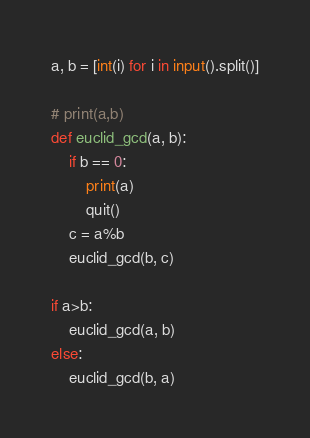Convert code to text. <code><loc_0><loc_0><loc_500><loc_500><_Python_>a, b = [int(i) for i in input().split()]

# print(a,b)
def euclid_gcd(a, b):
    if b == 0:
        print(a)
        quit()
    c = a%b
    euclid_gcd(b, c)

if a>b:
    euclid_gcd(a, b)
else:
    euclid_gcd(b, a)</code> 